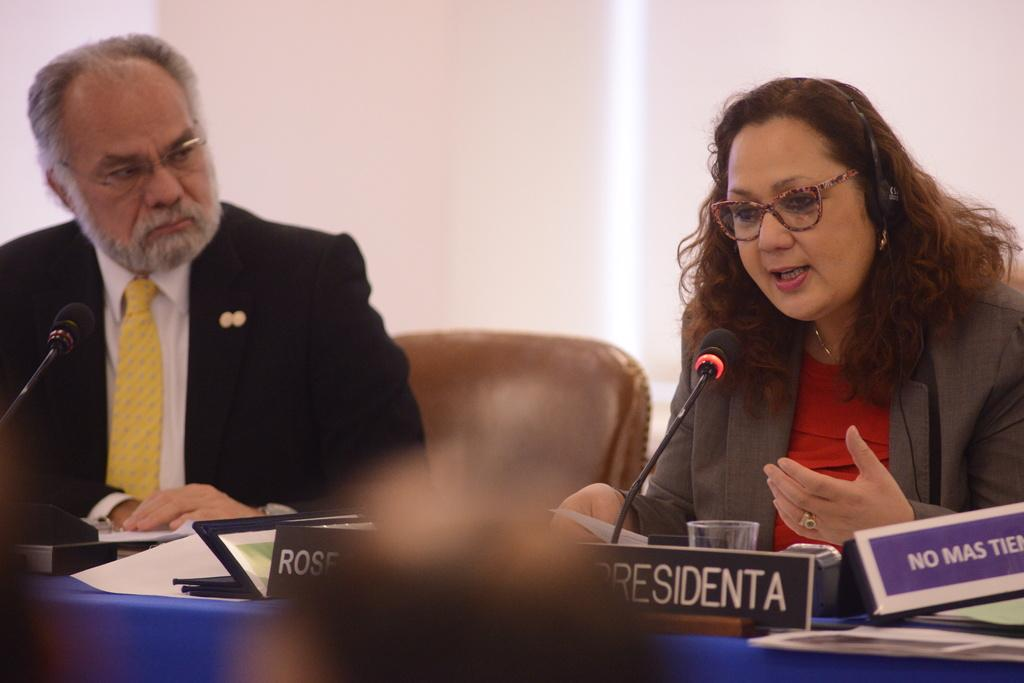How many people are in the image? There are two people in the image, a man and a woman. What are the man and woman doing in the image? Both the man and woman are sitting on chairs in the image. What is in front of the man and woman? There is a table in front of them. What type of animals can be seen on the table? There are mice on the table. What else can be seen on the table besides the mice? There are other things on the table. What type of icicle can be seen hanging from the man's chair in the image? There is no icicle present in the image; it is indoors and not cold enough for icicles to form. 